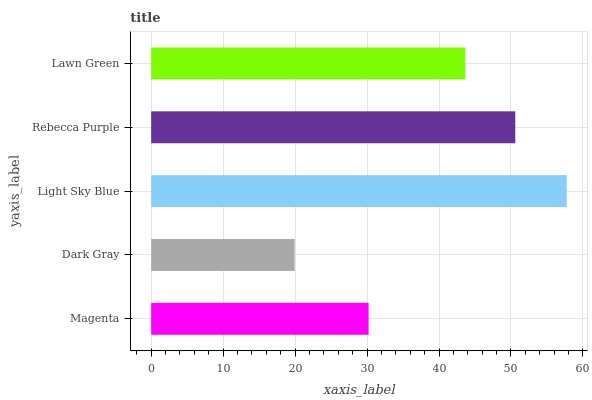Is Dark Gray the minimum?
Answer yes or no. Yes. Is Light Sky Blue the maximum?
Answer yes or no. Yes. Is Light Sky Blue the minimum?
Answer yes or no. No. Is Dark Gray the maximum?
Answer yes or no. No. Is Light Sky Blue greater than Dark Gray?
Answer yes or no. Yes. Is Dark Gray less than Light Sky Blue?
Answer yes or no. Yes. Is Dark Gray greater than Light Sky Blue?
Answer yes or no. No. Is Light Sky Blue less than Dark Gray?
Answer yes or no. No. Is Lawn Green the high median?
Answer yes or no. Yes. Is Lawn Green the low median?
Answer yes or no. Yes. Is Light Sky Blue the high median?
Answer yes or no. No. Is Magenta the low median?
Answer yes or no. No. 